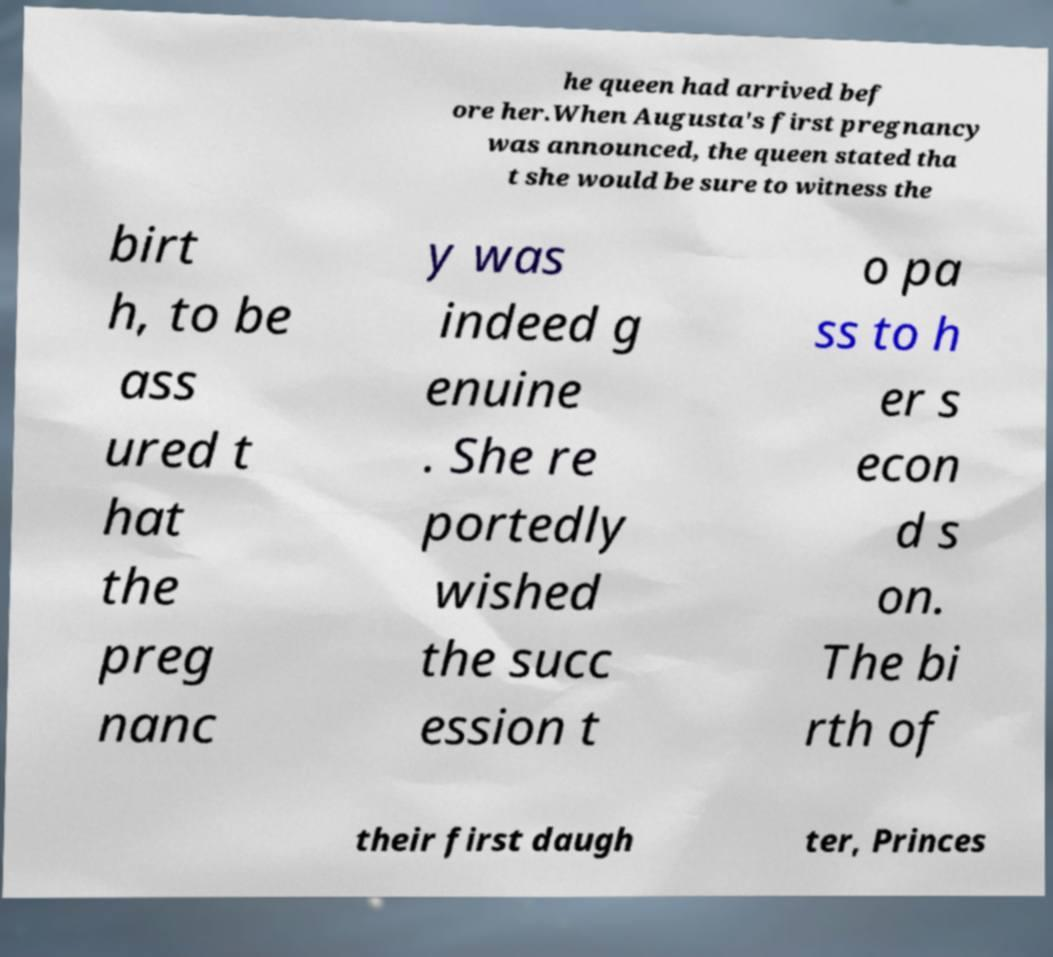Can you read and provide the text displayed in the image?This photo seems to have some interesting text. Can you extract and type it out for me? he queen had arrived bef ore her.When Augusta's first pregnancy was announced, the queen stated tha t she would be sure to witness the birt h, to be ass ured t hat the preg nanc y was indeed g enuine . She re portedly wished the succ ession t o pa ss to h er s econ d s on. The bi rth of their first daugh ter, Princes 